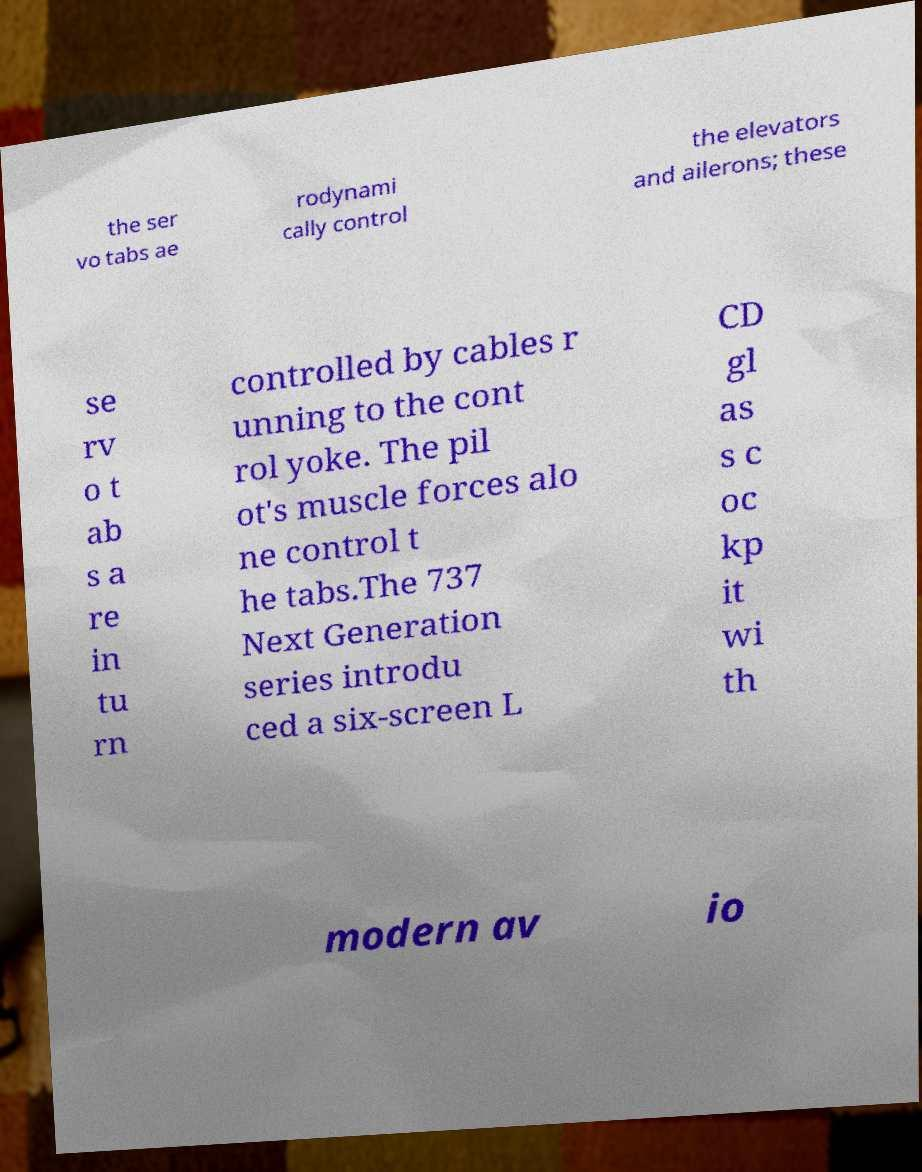What messages or text are displayed in this image? I need them in a readable, typed format. the ser vo tabs ae rodynami cally control the elevators and ailerons; these se rv o t ab s a re in tu rn controlled by cables r unning to the cont rol yoke. The pil ot's muscle forces alo ne control t he tabs.The 737 Next Generation series introdu ced a six-screen L CD gl as s c oc kp it wi th modern av io 